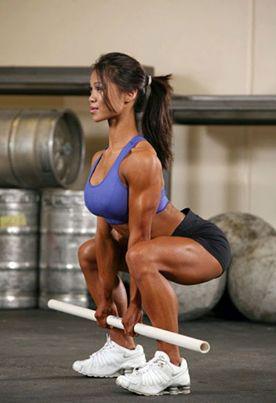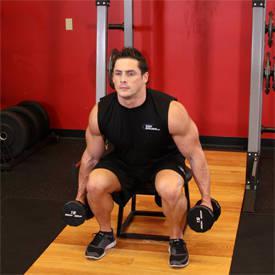The first image is the image on the left, the second image is the image on the right. Given the left and right images, does the statement "One of the guys does some leg-work near a red wall." hold true? Answer yes or no. Yes. The first image is the image on the left, the second image is the image on the right. Given the left and right images, does the statement "There is a man wearing a black shirt and black shorts with a dumbbell in each hand." hold true? Answer yes or no. Yes. 